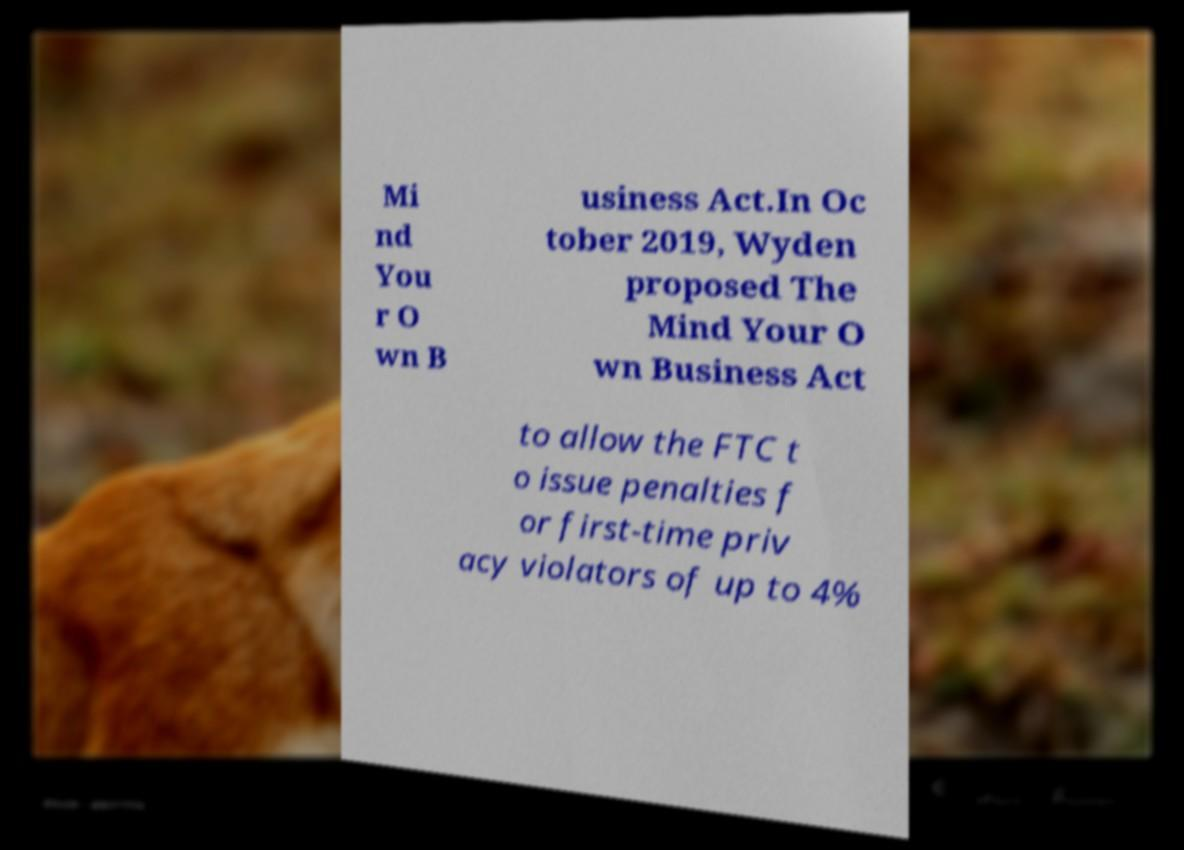There's text embedded in this image that I need extracted. Can you transcribe it verbatim? Mi nd You r O wn B usiness Act.In Oc tober 2019, Wyden proposed The Mind Your O wn Business Act to allow the FTC t o issue penalties f or first-time priv acy violators of up to 4% 